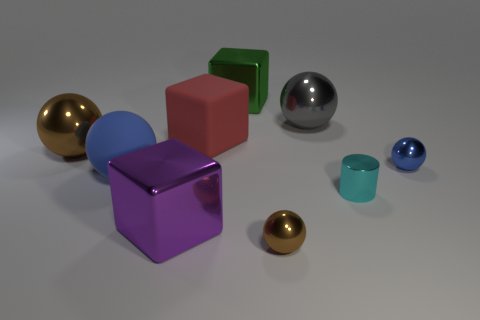What material is the brown thing on the right side of the large ball that is in front of the small blue metal sphere? The object in question appears to be a sphere with a reflective surface that gives it a brownish hue due to surrounding reflections. Since the question mentions it is on the right of the large ball and in front of another metal sphere, this brownish sphere is likely made of a polished metal, potentially brass or bronze, given its coloration and reflective quality. 